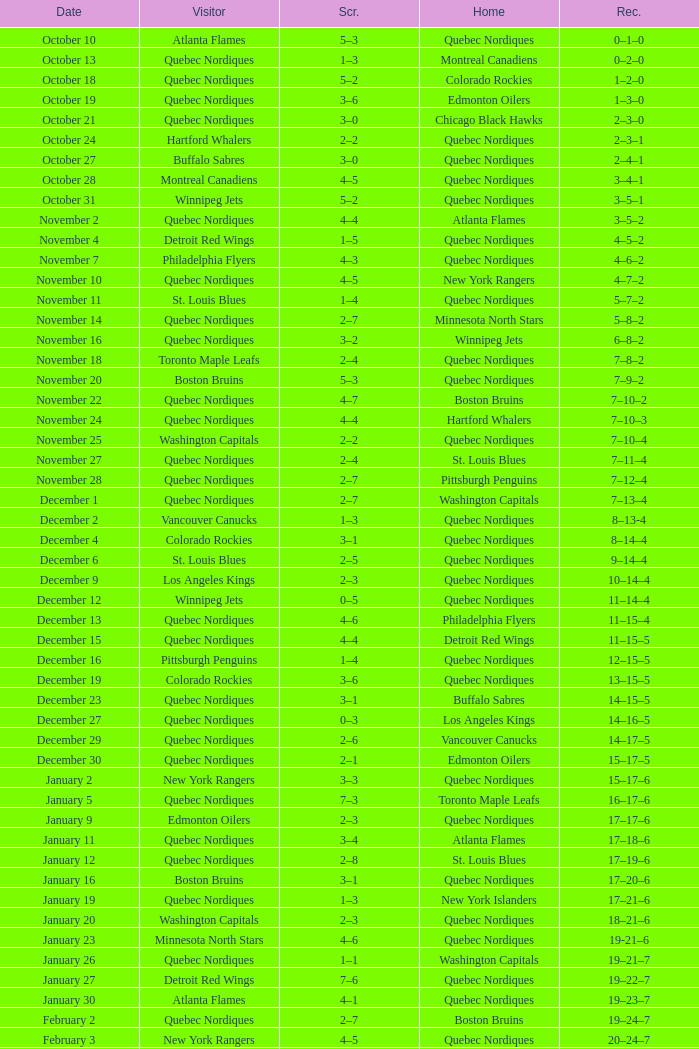Which Home has a Record of 11–14–4? Quebec Nordiques. Give me the full table as a dictionary. {'header': ['Date', 'Visitor', 'Scr.', 'Home', 'Rec.'], 'rows': [['October 10', 'Atlanta Flames', '5–3', 'Quebec Nordiques', '0–1–0'], ['October 13', 'Quebec Nordiques', '1–3', 'Montreal Canadiens', '0–2–0'], ['October 18', 'Quebec Nordiques', '5–2', 'Colorado Rockies', '1–2–0'], ['October 19', 'Quebec Nordiques', '3–6', 'Edmonton Oilers', '1–3–0'], ['October 21', 'Quebec Nordiques', '3–0', 'Chicago Black Hawks', '2–3–0'], ['October 24', 'Hartford Whalers', '2–2', 'Quebec Nordiques', '2–3–1'], ['October 27', 'Buffalo Sabres', '3–0', 'Quebec Nordiques', '2–4–1'], ['October 28', 'Montreal Canadiens', '4–5', 'Quebec Nordiques', '3–4–1'], ['October 31', 'Winnipeg Jets', '5–2', 'Quebec Nordiques', '3–5–1'], ['November 2', 'Quebec Nordiques', '4–4', 'Atlanta Flames', '3–5–2'], ['November 4', 'Detroit Red Wings', '1–5', 'Quebec Nordiques', '4–5–2'], ['November 7', 'Philadelphia Flyers', '4–3', 'Quebec Nordiques', '4–6–2'], ['November 10', 'Quebec Nordiques', '4–5', 'New York Rangers', '4–7–2'], ['November 11', 'St. Louis Blues', '1–4', 'Quebec Nordiques', '5–7–2'], ['November 14', 'Quebec Nordiques', '2–7', 'Minnesota North Stars', '5–8–2'], ['November 16', 'Quebec Nordiques', '3–2', 'Winnipeg Jets', '6–8–2'], ['November 18', 'Toronto Maple Leafs', '2–4', 'Quebec Nordiques', '7–8–2'], ['November 20', 'Boston Bruins', '5–3', 'Quebec Nordiques', '7–9–2'], ['November 22', 'Quebec Nordiques', '4–7', 'Boston Bruins', '7–10–2'], ['November 24', 'Quebec Nordiques', '4–4', 'Hartford Whalers', '7–10–3'], ['November 25', 'Washington Capitals', '2–2', 'Quebec Nordiques', '7–10–4'], ['November 27', 'Quebec Nordiques', '2–4', 'St. Louis Blues', '7–11–4'], ['November 28', 'Quebec Nordiques', '2–7', 'Pittsburgh Penguins', '7–12–4'], ['December 1', 'Quebec Nordiques', '2–7', 'Washington Capitals', '7–13–4'], ['December 2', 'Vancouver Canucks', '1–3', 'Quebec Nordiques', '8–13-4'], ['December 4', 'Colorado Rockies', '3–1', 'Quebec Nordiques', '8–14–4'], ['December 6', 'St. Louis Blues', '2–5', 'Quebec Nordiques', '9–14–4'], ['December 9', 'Los Angeles Kings', '2–3', 'Quebec Nordiques', '10–14–4'], ['December 12', 'Winnipeg Jets', '0–5', 'Quebec Nordiques', '11–14–4'], ['December 13', 'Quebec Nordiques', '4–6', 'Philadelphia Flyers', '11–15–4'], ['December 15', 'Quebec Nordiques', '4–4', 'Detroit Red Wings', '11–15–5'], ['December 16', 'Pittsburgh Penguins', '1–4', 'Quebec Nordiques', '12–15–5'], ['December 19', 'Colorado Rockies', '3–6', 'Quebec Nordiques', '13–15–5'], ['December 23', 'Quebec Nordiques', '3–1', 'Buffalo Sabres', '14–15–5'], ['December 27', 'Quebec Nordiques', '0–3', 'Los Angeles Kings', '14–16–5'], ['December 29', 'Quebec Nordiques', '2–6', 'Vancouver Canucks', '14–17–5'], ['December 30', 'Quebec Nordiques', '2–1', 'Edmonton Oilers', '15–17–5'], ['January 2', 'New York Rangers', '3–3', 'Quebec Nordiques', '15–17–6'], ['January 5', 'Quebec Nordiques', '7–3', 'Toronto Maple Leafs', '16–17–6'], ['January 9', 'Edmonton Oilers', '2–3', 'Quebec Nordiques', '17–17–6'], ['January 11', 'Quebec Nordiques', '3–4', 'Atlanta Flames', '17–18–6'], ['January 12', 'Quebec Nordiques', '2–8', 'St. Louis Blues', '17–19–6'], ['January 16', 'Boston Bruins', '3–1', 'Quebec Nordiques', '17–20–6'], ['January 19', 'Quebec Nordiques', '1–3', 'New York Islanders', '17–21–6'], ['January 20', 'Washington Capitals', '2–3', 'Quebec Nordiques', '18–21–6'], ['January 23', 'Minnesota North Stars', '4–6', 'Quebec Nordiques', '19-21–6'], ['January 26', 'Quebec Nordiques', '1–1', 'Washington Capitals', '19–21–7'], ['January 27', 'Detroit Red Wings', '7–6', 'Quebec Nordiques', '19–22–7'], ['January 30', 'Atlanta Flames', '4–1', 'Quebec Nordiques', '19–23–7'], ['February 2', 'Quebec Nordiques', '2–7', 'Boston Bruins', '19–24–7'], ['February 3', 'New York Rangers', '4–5', 'Quebec Nordiques', '20–24–7'], ['February 6', 'Chicago Black Hawks', '3–3', 'Quebec Nordiques', '20–24–8'], ['February 9', 'Quebec Nordiques', '0–5', 'New York Islanders', '20–25–8'], ['February 10', 'Quebec Nordiques', '1–3', 'New York Rangers', '20–26–8'], ['February 14', 'Quebec Nordiques', '1–5', 'Montreal Canadiens', '20–27–8'], ['February 17', 'Quebec Nordiques', '5–6', 'Winnipeg Jets', '20–28–8'], ['February 18', 'Quebec Nordiques', '2–6', 'Minnesota North Stars', '20–29–8'], ['February 19', 'Buffalo Sabres', '3–1', 'Quebec Nordiques', '20–30–8'], ['February 23', 'Quebec Nordiques', '1–2', 'Pittsburgh Penguins', '20–31–8'], ['February 24', 'Pittsburgh Penguins', '0–2', 'Quebec Nordiques', '21–31–8'], ['February 26', 'Hartford Whalers', '5–9', 'Quebec Nordiques', '22–31–8'], ['February 27', 'New York Islanders', '5–3', 'Quebec Nordiques', '22–32–8'], ['March 2', 'Los Angeles Kings', '4–3', 'Quebec Nordiques', '22–33–8'], ['March 5', 'Minnesota North Stars', '3-3', 'Quebec Nordiques', '22–33–9'], ['March 8', 'Quebec Nordiques', '2–3', 'Toronto Maple Leafs', '22–34–9'], ['March 9', 'Toronto Maple Leafs', '4–5', 'Quebec Nordiques', '23–34-9'], ['March 12', 'Edmonton Oilers', '6–3', 'Quebec Nordiques', '23–35–9'], ['March 16', 'Vancouver Canucks', '3–2', 'Quebec Nordiques', '23–36–9'], ['March 19', 'Quebec Nordiques', '2–5', 'Chicago Black Hawks', '23–37–9'], ['March 20', 'Quebec Nordiques', '6–2', 'Colorado Rockies', '24–37–9'], ['March 22', 'Quebec Nordiques', '1-4', 'Los Angeles Kings', '24–38-9'], ['March 23', 'Quebec Nordiques', '6–2', 'Vancouver Canucks', '25–38–9'], ['March 26', 'Chicago Black Hawks', '7–2', 'Quebec Nordiques', '25–39–9'], ['March 27', 'Quebec Nordiques', '2–5', 'Philadelphia Flyers', '25–40–9'], ['March 29', 'Quebec Nordiques', '7–9', 'Detroit Red Wings', '25–41–9'], ['March 30', 'New York Islanders', '9–6', 'Quebec Nordiques', '25–42–9'], ['April 1', 'Philadelphia Flyers', '3–3', 'Quebec Nordiques', '25–42–10'], ['April 3', 'Quebec Nordiques', '3–8', 'Buffalo Sabres', '25–43–10'], ['April 4', 'Quebec Nordiques', '2–9', 'Hartford Whalers', '25–44–10'], ['April 6', 'Montreal Canadiens', '4–4', 'Quebec Nordiques', '25–44–11']]} 